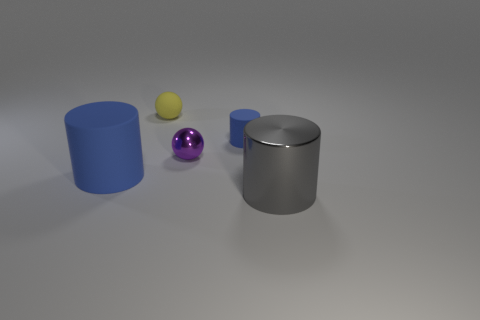Do the blue matte cylinder that is to the left of the small blue thing and the shiny thing that is behind the gray thing have the same size?
Provide a short and direct response. No. There is a gray metallic thing that is the same shape as the large matte object; what size is it?
Offer a very short reply. Large. Does the gray cylinder have the same size as the blue cylinder that is to the left of the yellow matte thing?
Provide a succinct answer. Yes. Is there a large gray cylinder that is left of the blue cylinder that is to the right of the tiny yellow matte sphere?
Provide a short and direct response. No. What shape is the tiny object in front of the tiny matte cylinder?
Your answer should be compact. Sphere. What is the material of the other cylinder that is the same color as the small matte cylinder?
Give a very brief answer. Rubber. The object that is in front of the blue matte cylinder that is left of the small yellow ball is what color?
Your response must be concise. Gray. Is the purple shiny thing the same size as the yellow sphere?
Your answer should be compact. Yes. There is a purple object that is the same shape as the small yellow rubber thing; what material is it?
Provide a succinct answer. Metal. How many gray cylinders have the same size as the yellow rubber sphere?
Ensure brevity in your answer.  0. 